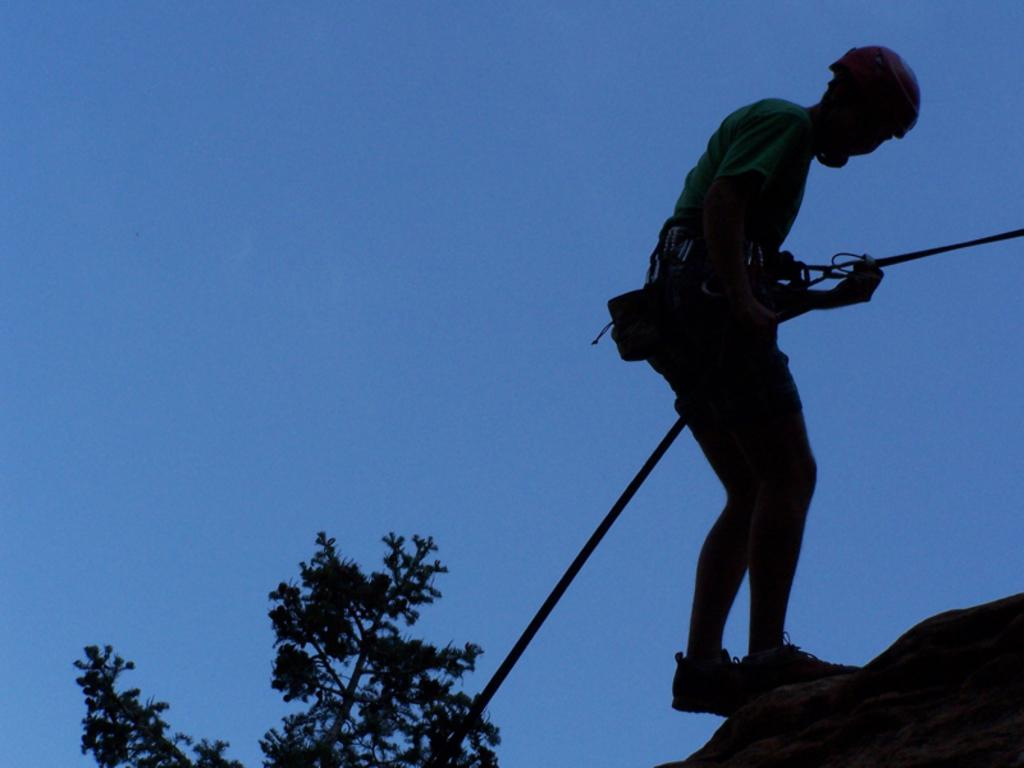What is the person in the image doing? The person is climbing in the image. What object is located beside the person? There is a stone beside the person. What type of plant can be seen in the image? There is a tree in the image. What is visible at the top of the image? The sky is visible at the top of the image. What type of engine can be seen powering the person's climb in the image? There is no engine present in the image; the person is climbing without any mechanical assistance. Can you see the person's home in the image? There is no information about the person's home in the image, as it only shows the person climbing and the surrounding environment. 